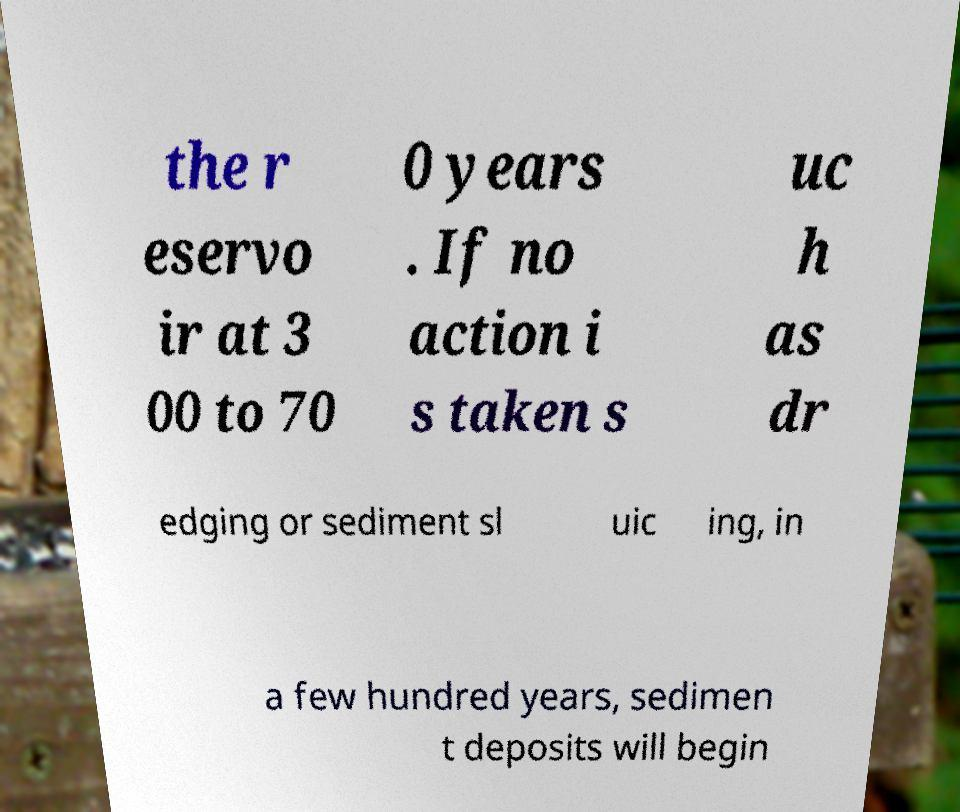Please identify and transcribe the text found in this image. the r eservo ir at 3 00 to 70 0 years . If no action i s taken s uc h as dr edging or sediment sl uic ing, in a few hundred years, sedimen t deposits will begin 